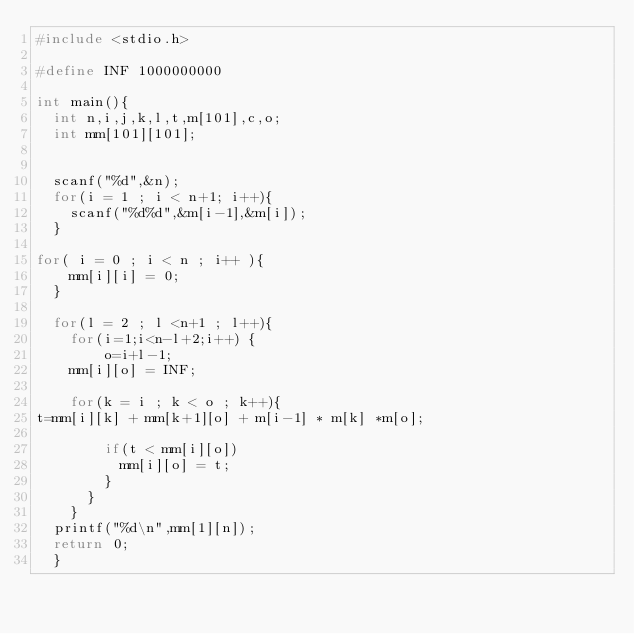<code> <loc_0><loc_0><loc_500><loc_500><_C_>#include <stdio.h>
 
#define INF 1000000000
 
int main(){
  int n,i,j,k,l,t,m[101],c,o;
  int mm[101][101];
  
  
  scanf("%d",&n);
  for(i = 1 ; i < n+1; i++){
    scanf("%d%d",&m[i-1],&m[i]);
  }
  
for( i = 0 ; i < n ; i++ ){
    mm[i][i] = 0;
  }  
  
  for(l = 2 ; l <n+1 ; l++){
  	for(i=1;i<n-l+2;i++) {
  		o=i+l-1;
    mm[i][o] = INF;
  
    for(k = i ; k < o ; k++){
t=mm[i][k] + mm[k+1][o] + m[i-1] * m[k] *m[o];

        if(t < mm[i][o])
          mm[i][o] = t;
        }
      }
    }
  printf("%d\n",mm[1][n]);
  return 0;
  }
</code> 